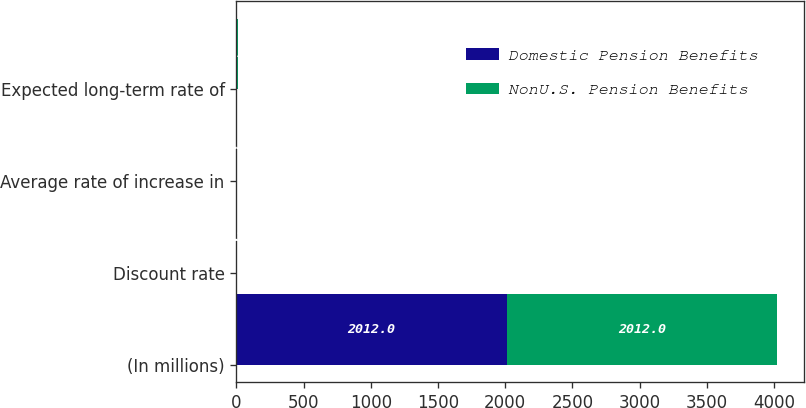Convert chart. <chart><loc_0><loc_0><loc_500><loc_500><stacked_bar_chart><ecel><fcel>(In millions)<fcel>Discount rate<fcel>Average rate of increase in<fcel>Expected long-term rate of<nl><fcel>Domestic Pension Benefits<fcel>2012<fcel>4.5<fcel>4<fcel>7.75<nl><fcel>NonU.S. Pension Benefits<fcel>2012<fcel>4.37<fcel>3.23<fcel>5.17<nl></chart> 